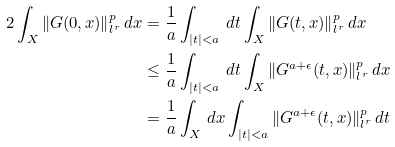Convert formula to latex. <formula><loc_0><loc_0><loc_500><loc_500>2 \int _ { X } \| G ( 0 , x ) \| _ { l ^ { r } } ^ { p } \, d x & = \frac { 1 } { a } \int _ { | t | < a } \, d t \int _ { X } \| G ( t , x ) \| _ { l ^ { r } } ^ { p } \, d x \\ & \leq \frac { 1 } { a } \int _ { | t | < a } \, d t \int _ { X } \| G ^ { a + \epsilon } ( t , x ) \| _ { l ^ { r } } ^ { p } \, d x \\ & = \frac { 1 } { a } \int _ { X } \, d x \int _ { | t | < a } \| G ^ { a + \epsilon } ( t , x ) \| _ { l ^ { r } } ^ { p } \, d t</formula> 